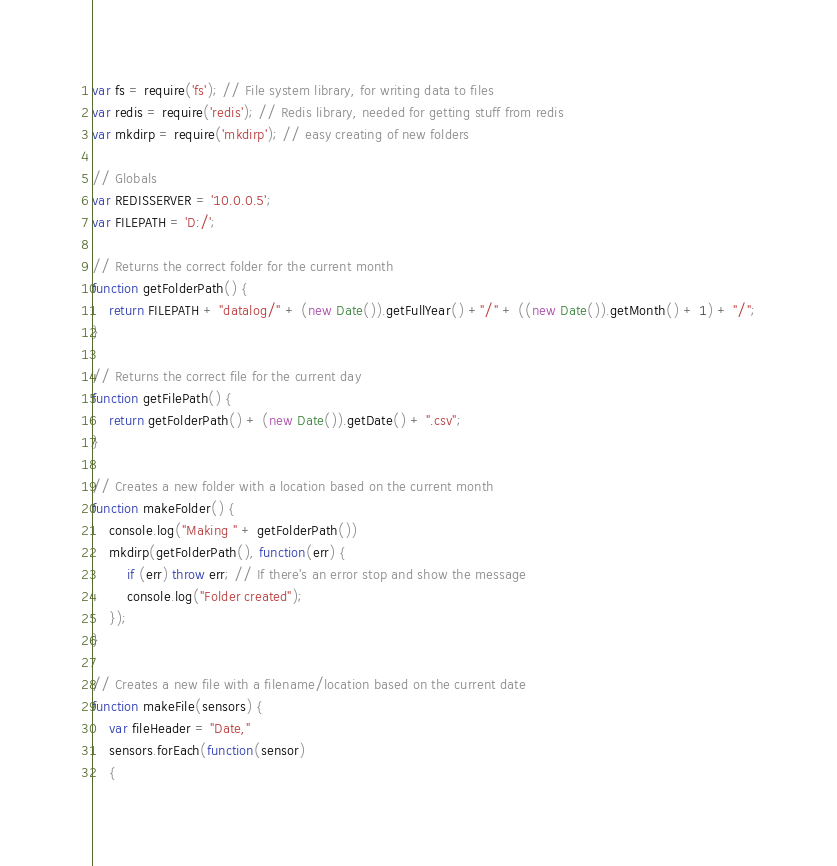<code> <loc_0><loc_0><loc_500><loc_500><_JavaScript_>var fs = require('fs'); // File system library, for writing data to files
var redis = require('redis'); // Redis library, needed for getting stuff from redis
var mkdirp = require('mkdirp'); // easy creating of new folders

// Globals
var REDISSERVER = '10.0.0.5';
var FILEPATH = 'D:/';

// Returns the correct folder for the current month
function getFolderPath() {
	return FILEPATH + "datalog/" + (new Date()).getFullYear() +"/" + ((new Date()).getMonth() + 1) + "/";
}

// Returns the correct file for the current day
function getFilePath() {
	return getFolderPath() + (new Date()).getDate() + ".csv";
}

// Creates a new folder with a location based on the current month
function makeFolder() {
	console.log("Making " + getFolderPath())
	mkdirp(getFolderPath(), function(err) {
		if (err) throw err; // If there's an error stop and show the message
		console.log("Folder created");
	});
}

// Creates a new file with a filename/location based on the current date
function makeFile(sensors) {
	var fileHeader = "Date,"
	sensors.forEach(function(sensor) 
	{ </code> 